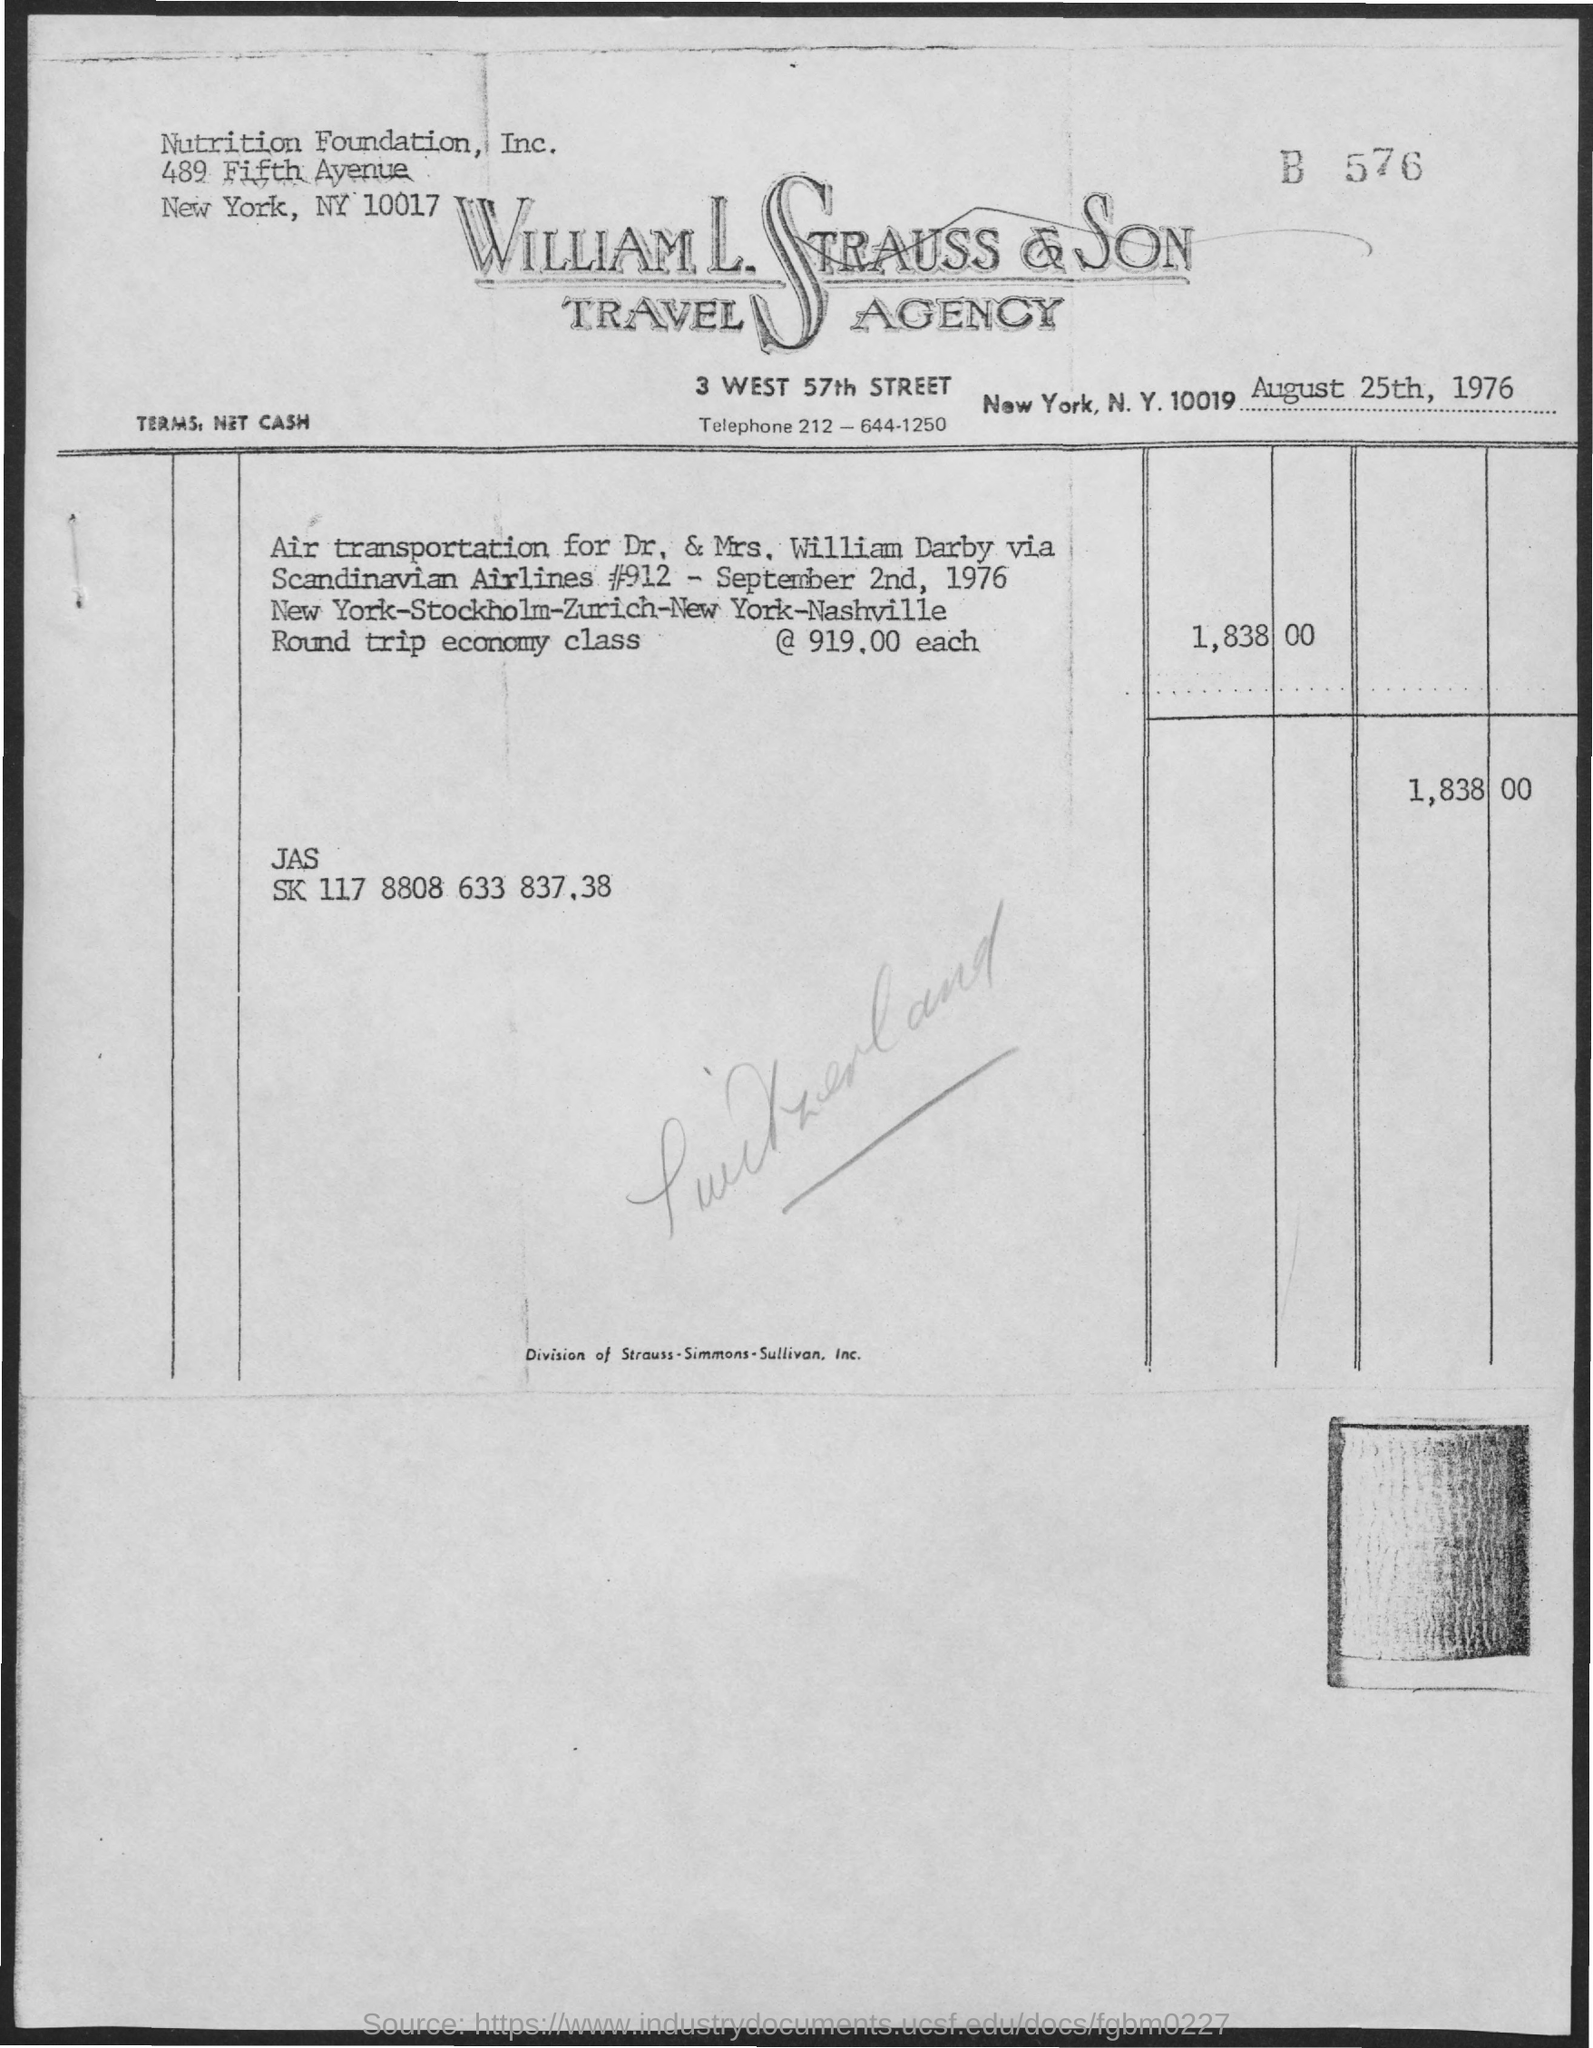Point out several critical features in this image. The date on the document is August 25th, 1976. 